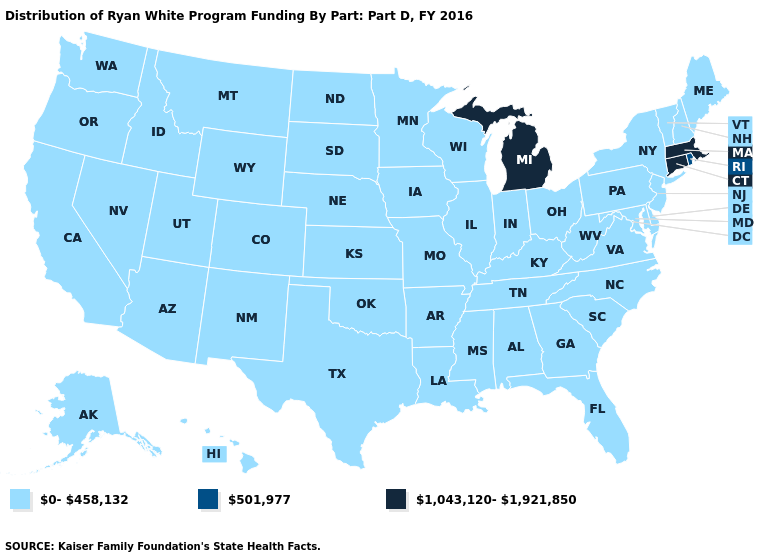Does California have a lower value than Connecticut?
Answer briefly. Yes. What is the value of Maryland?
Keep it brief. 0-458,132. Does the first symbol in the legend represent the smallest category?
Keep it brief. Yes. Name the states that have a value in the range 1,043,120-1,921,850?
Concise answer only. Connecticut, Massachusetts, Michigan. What is the value of Missouri?
Short answer required. 0-458,132. Name the states that have a value in the range 0-458,132?
Give a very brief answer. Alabama, Alaska, Arizona, Arkansas, California, Colorado, Delaware, Florida, Georgia, Hawaii, Idaho, Illinois, Indiana, Iowa, Kansas, Kentucky, Louisiana, Maine, Maryland, Minnesota, Mississippi, Missouri, Montana, Nebraska, Nevada, New Hampshire, New Jersey, New Mexico, New York, North Carolina, North Dakota, Ohio, Oklahoma, Oregon, Pennsylvania, South Carolina, South Dakota, Tennessee, Texas, Utah, Vermont, Virginia, Washington, West Virginia, Wisconsin, Wyoming. What is the value of Pennsylvania?
Give a very brief answer. 0-458,132. Does the map have missing data?
Write a very short answer. No. What is the value of Georgia?
Give a very brief answer. 0-458,132. Name the states that have a value in the range 501,977?
Keep it brief. Rhode Island. How many symbols are there in the legend?
Quick response, please. 3. What is the value of New York?
Keep it brief. 0-458,132. What is the value of Rhode Island?
Concise answer only. 501,977. Name the states that have a value in the range 0-458,132?
Write a very short answer. Alabama, Alaska, Arizona, Arkansas, California, Colorado, Delaware, Florida, Georgia, Hawaii, Idaho, Illinois, Indiana, Iowa, Kansas, Kentucky, Louisiana, Maine, Maryland, Minnesota, Mississippi, Missouri, Montana, Nebraska, Nevada, New Hampshire, New Jersey, New Mexico, New York, North Carolina, North Dakota, Ohio, Oklahoma, Oregon, Pennsylvania, South Carolina, South Dakota, Tennessee, Texas, Utah, Vermont, Virginia, Washington, West Virginia, Wisconsin, Wyoming. 